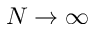<formula> <loc_0><loc_0><loc_500><loc_500>N \to \infty</formula> 